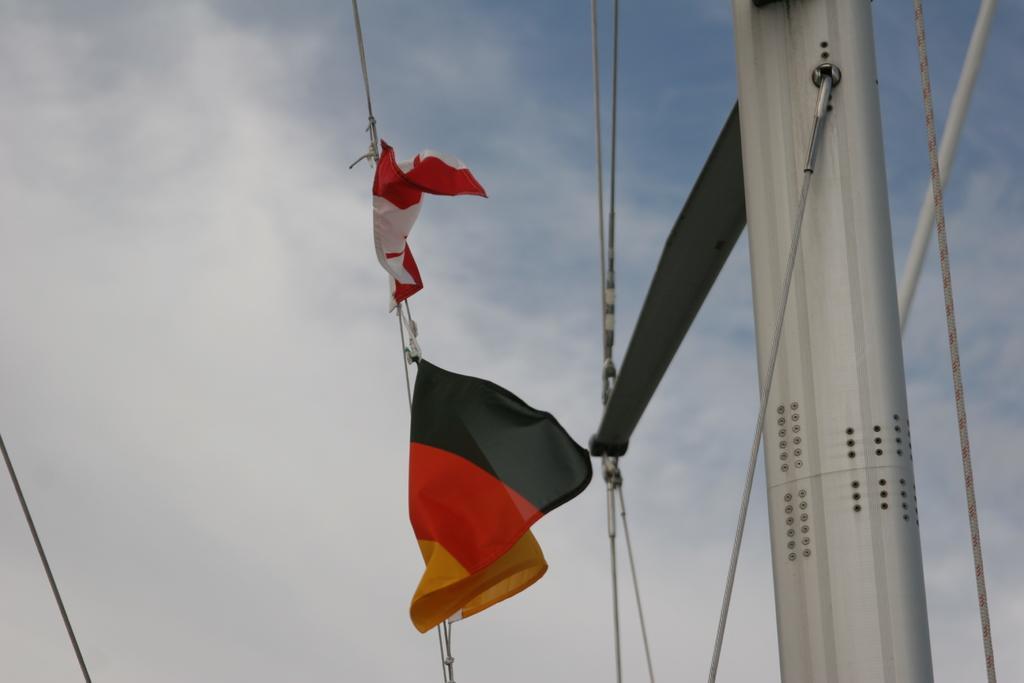Can you describe this image briefly? This image is taken outdoors. In the background there is the sky with clouds. On the right side of the image there is an iron bar and there are a few metal rods and wires. In the middle of the image there are two flags. 